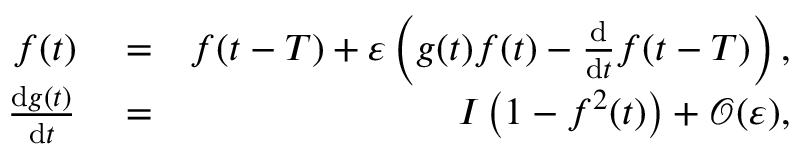<formula> <loc_0><loc_0><loc_500><loc_500>\begin{array} { r l r } { f ( t ) } & = } & { f ( t - T ) + \varepsilon \left ( g ( t ) f ( t ) - \frac { d } { d t } f ( t - T ) \right ) , } \\ { \frac { d g ( t ) } { d t } } & = } & { I \left ( 1 - f ^ { 2 } ( t ) \right ) + \mathcal { O } ( \varepsilon ) , } \end{array}</formula> 